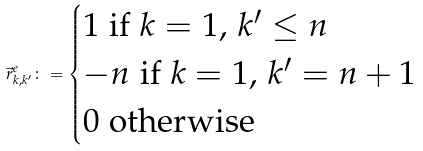Convert formula to latex. <formula><loc_0><loc_0><loc_500><loc_500>\vec { r } ^ { e } _ { k , k ^ { \prime } } \colon = \begin{cases} 1 \text { if $k= 1, \, k^{\prime}\leq n$} \\ - n \text { if $k= 1, \, k^{\prime}= n+1$} \\ 0 \text { otherwise} \end{cases}</formula> 